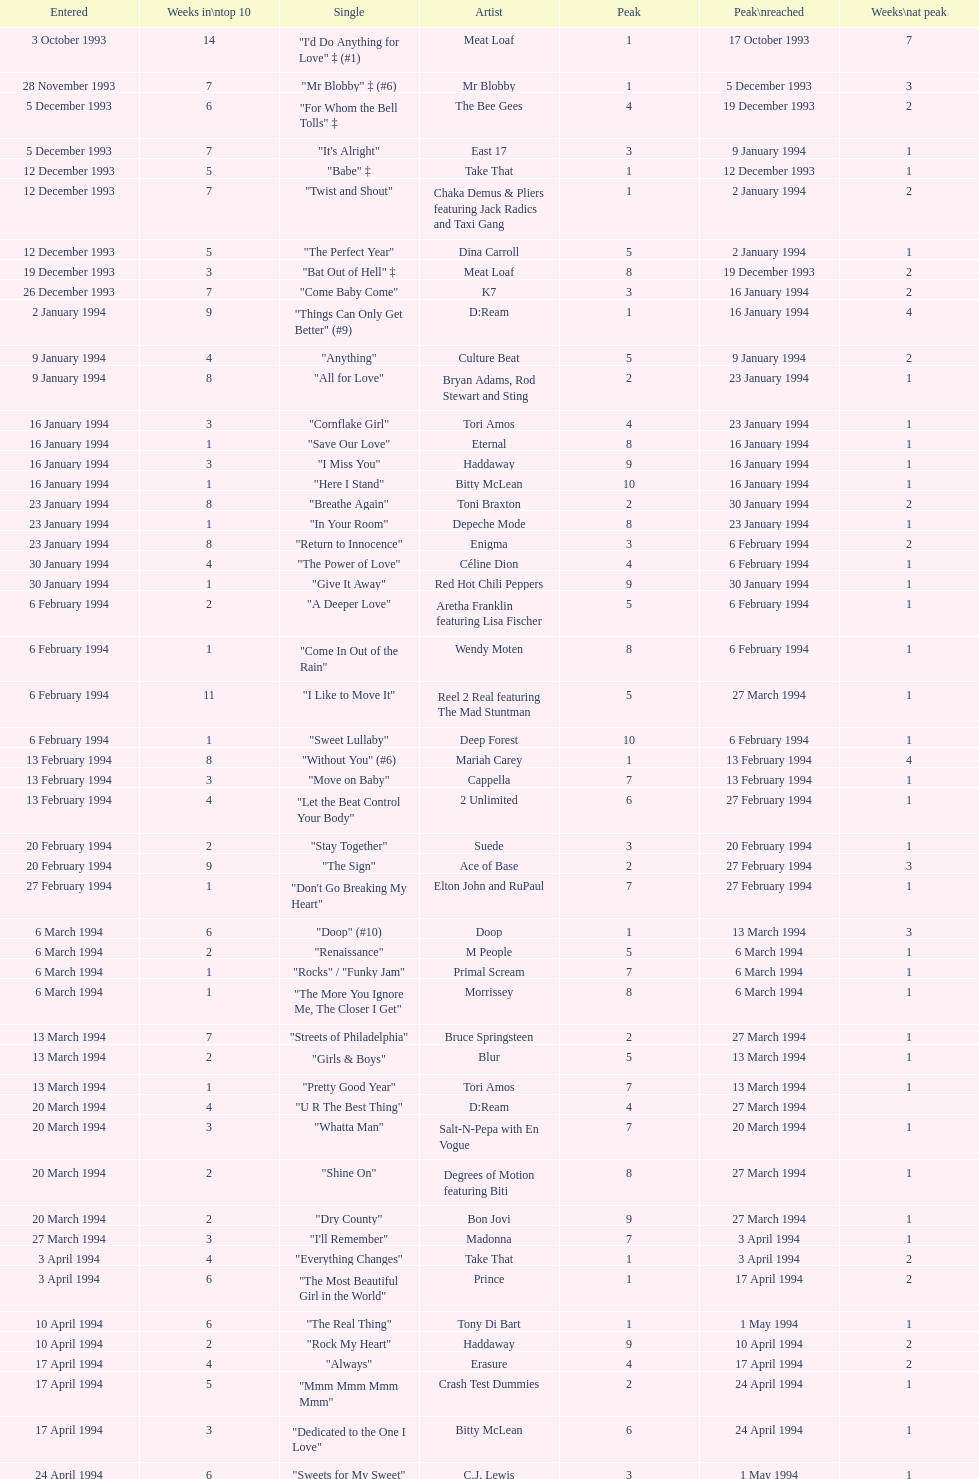What is the first entered date? 3 October 1993. 